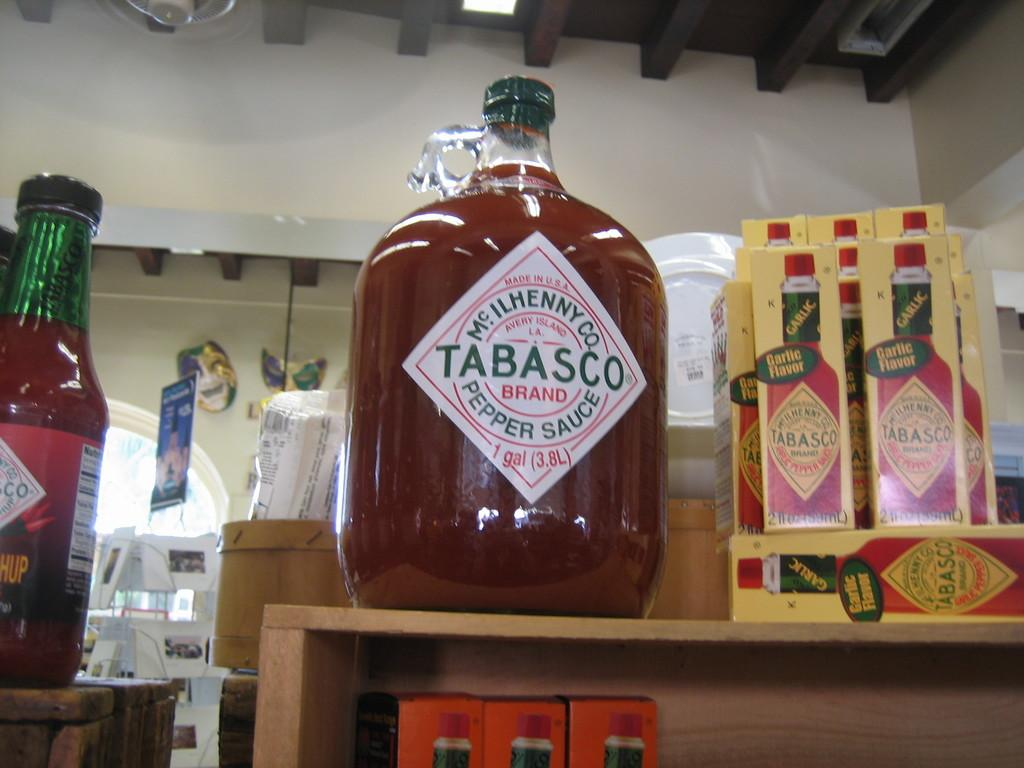<image>
Give a short and clear explanation of the subsequent image. A huge bottle of Tabasco sits on a shelf next to boxes of smaller bottles. 